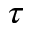<formula> <loc_0><loc_0><loc_500><loc_500>\tau</formula> 